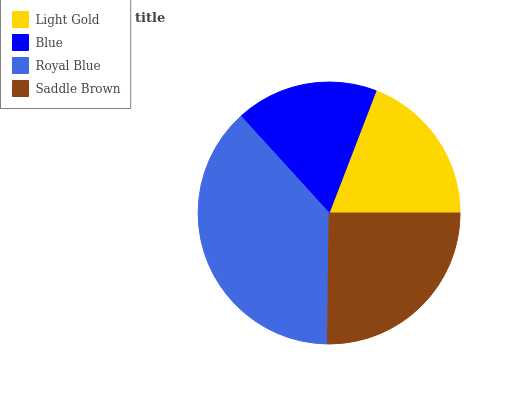Is Blue the minimum?
Answer yes or no. Yes. Is Royal Blue the maximum?
Answer yes or no. Yes. Is Royal Blue the minimum?
Answer yes or no. No. Is Blue the maximum?
Answer yes or no. No. Is Royal Blue greater than Blue?
Answer yes or no. Yes. Is Blue less than Royal Blue?
Answer yes or no. Yes. Is Blue greater than Royal Blue?
Answer yes or no. No. Is Royal Blue less than Blue?
Answer yes or no. No. Is Saddle Brown the high median?
Answer yes or no. Yes. Is Light Gold the low median?
Answer yes or no. Yes. Is Blue the high median?
Answer yes or no. No. Is Royal Blue the low median?
Answer yes or no. No. 